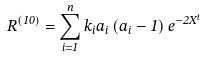<formula> <loc_0><loc_0><loc_500><loc_500>R ^ { \left ( 1 0 \right ) } = \sum _ { i = 1 } ^ { n } k _ { i } a _ { i } \left ( a _ { i } - 1 \right ) e ^ { - 2 X ^ { i } }</formula> 